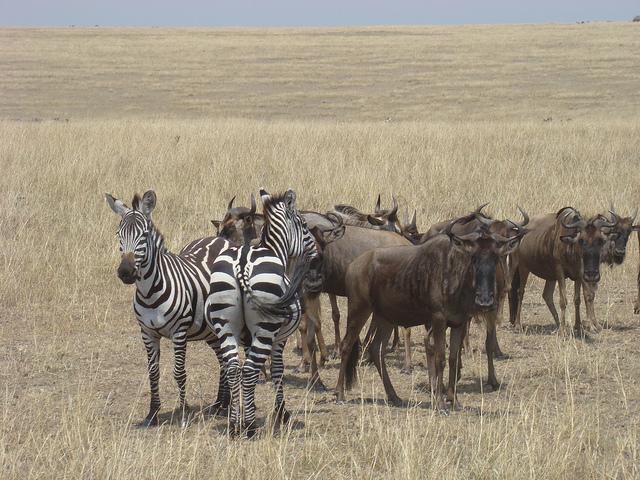What type of excursion could one go on to see these animals?
Answer briefly. Safari. How many zebras are seen?
Quick response, please. 2. Is the grass green?
Write a very short answer. No. How many animals are there?
Be succinct. 8. How many zebras are looking at the camera?
Short answer required. 1. 